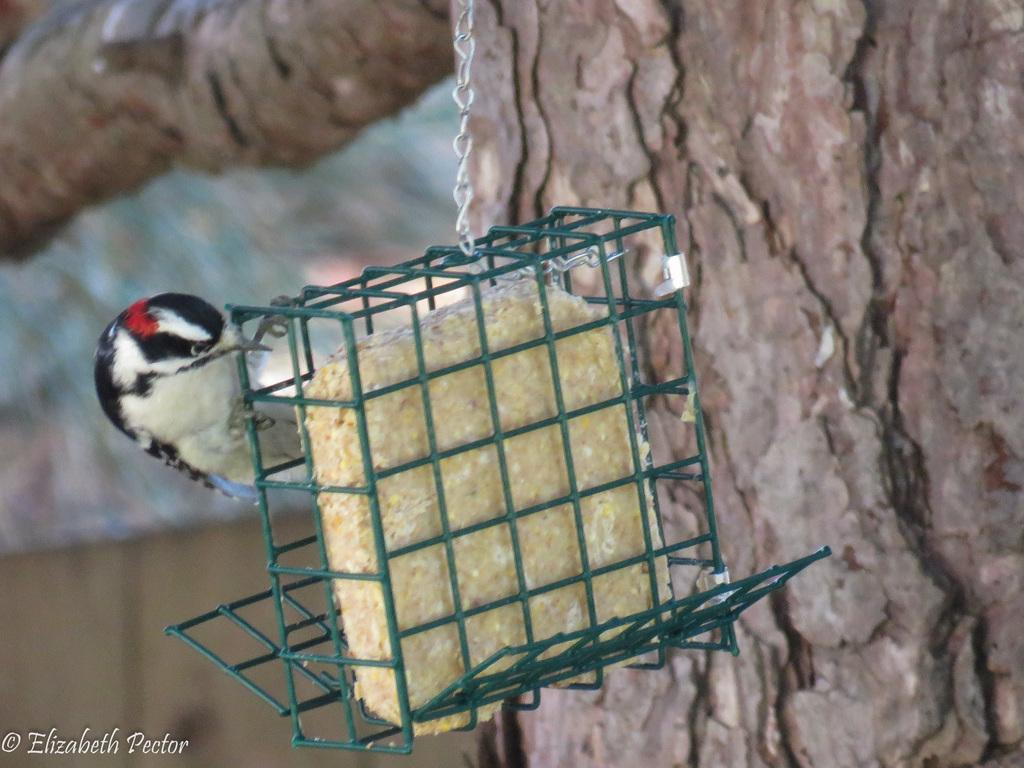What type of animal is present in the image? There is a bird in the image. Where is the bird located? The bird is in a cage. How is the cage attached to the tree trunk? The cage is fixed to a tree trunk. What type of fruit is being used as a guide for the bird in the image? There is no fruit present in the image, and the bird is not being guided by any object. 